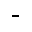Convert formula to latex. <formula><loc_0><loc_0><loc_500><loc_500>-</formula> 